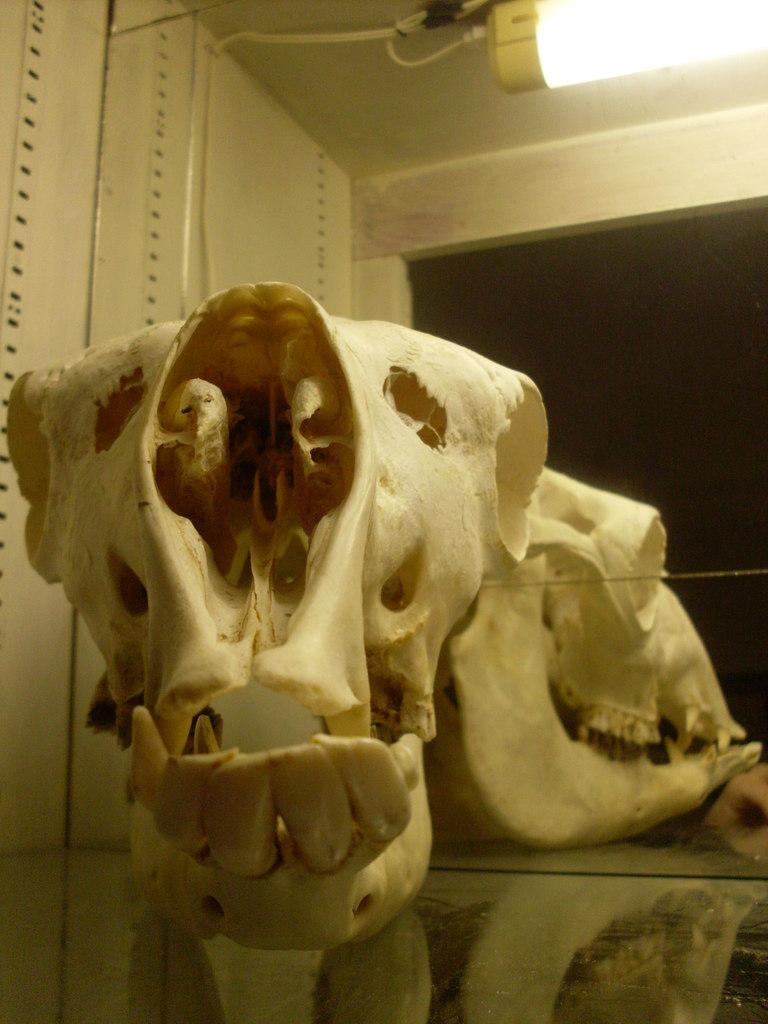What is the main object in the image? There is a skull in the image. What other object can be seen in the image? There is a glass in the image. What can be seen in the background of the image? There is a light and a wall in the background of the image. What type of minister is present in the image? There is no minister present in the image. 